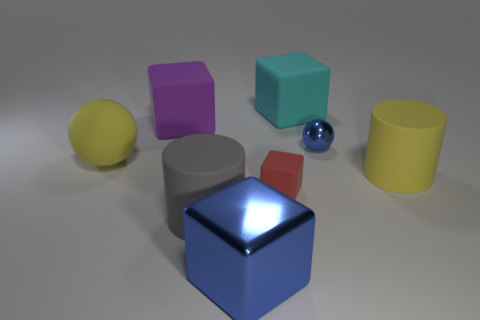Is the size of the purple rubber block the same as the gray cylinder?
Keep it short and to the point. Yes. How big is the metallic thing behind the blue metal thing to the left of the red rubber thing?
Your answer should be compact. Small. There is a rubber thing that is both behind the blue ball and left of the gray thing; what is its size?
Make the answer very short. Large. What number of yellow rubber objects are the same size as the cyan thing?
Provide a succinct answer. 2. What number of rubber objects are either purple blocks or big cyan things?
Offer a very short reply. 2. What is the size of the metal object that is the same color as the big shiny block?
Keep it short and to the point. Small. What is the material of the yellow object to the left of the blue object to the left of the cyan cube?
Your answer should be compact. Rubber. What number of things are either large yellow metallic balls or yellow matte things on the right side of the blue metal sphere?
Give a very brief answer. 1. The red block that is made of the same material as the large yellow sphere is what size?
Keep it short and to the point. Small. How many brown objects are either rubber spheres or rubber objects?
Your answer should be very brief. 0. 